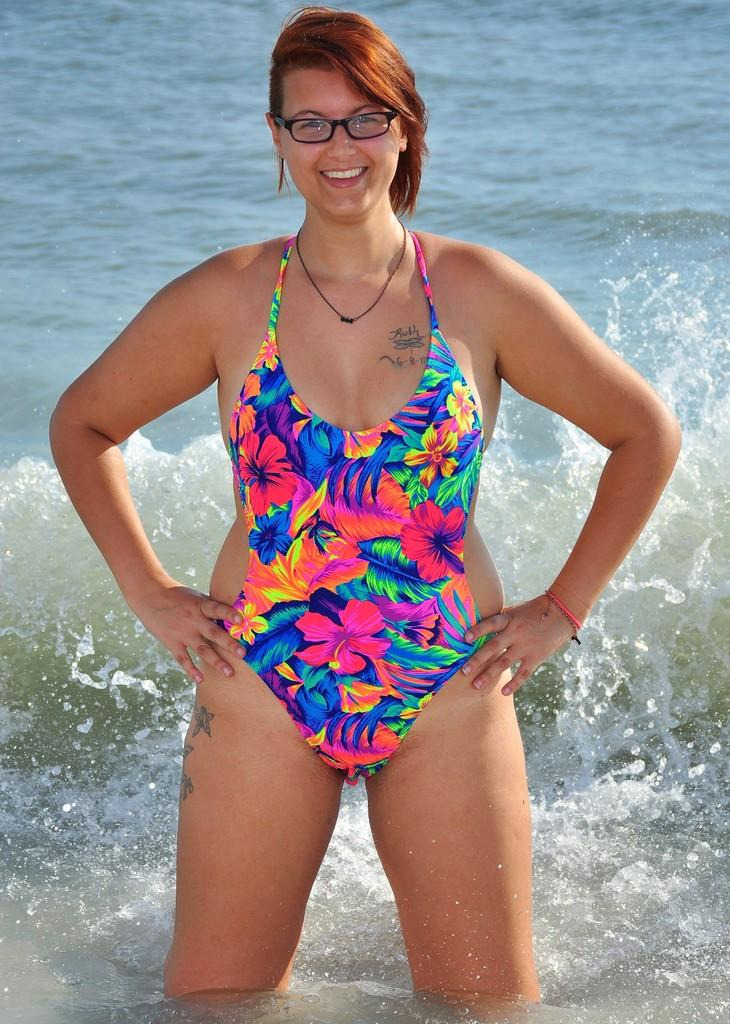Who is present in the image? There is a woman in the image. What is the woman doing in the image? The woman is standing on the water. What is the woman's facial expression in the image? The woman is smiling. What type of canvas is visible in the image? There is no canvas present in the image. What force is responsible for the woman standing on the water in the image? The image does not provide information about the force that allows the woman to stand on the water. 